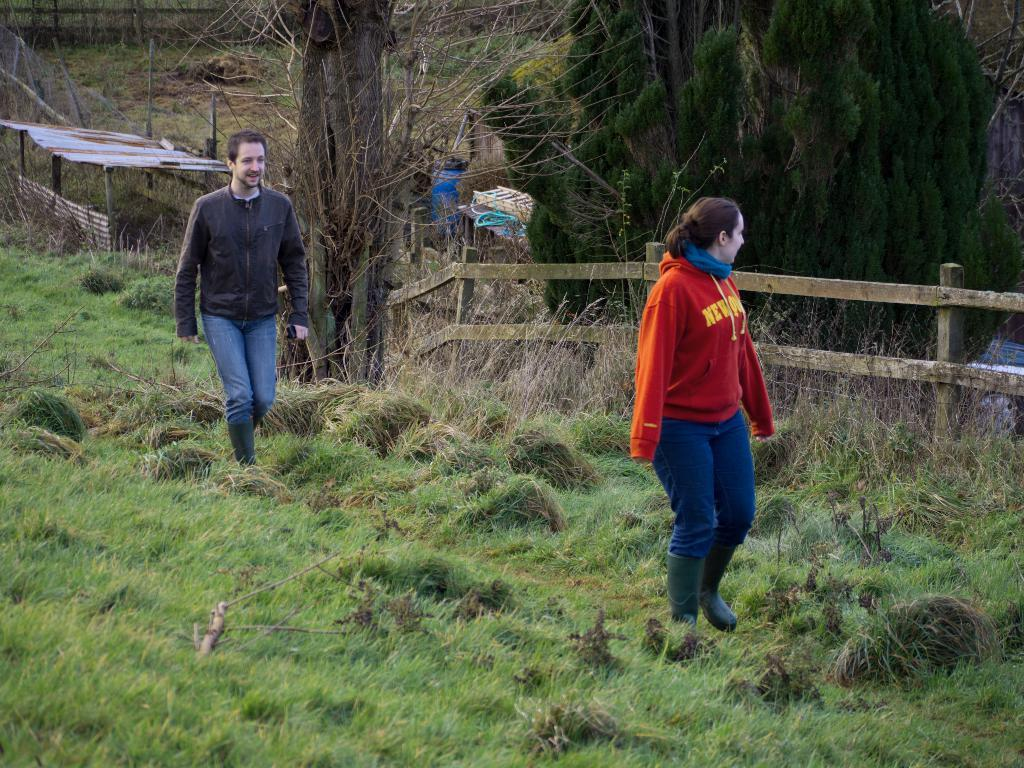What are the two people in the image doing? The two people in the image are walking. On what surface are the people walking? The people are walking on the grass. What can be seen in the background of the image? In the background of the image, there is a shelter, fences, trees, and some unspecified objects. What type of pan is being used by one of the people in the image? There is no pan present in the image; the two people are simply walking on the grass. Can you tell me how many toothbrushes are visible in the image? There are no toothbrushes visible in the image. 